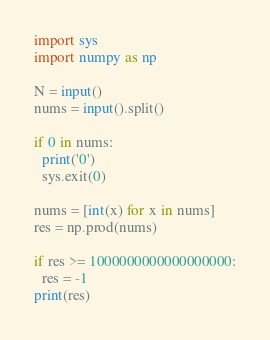Convert code to text. <code><loc_0><loc_0><loc_500><loc_500><_Python_>import sys
import numpy as np

N = input()
nums = input().split()
 
if 0 in nums:
  print('0')
  sys.exit(0)

nums = [int(x) for x in nums]
res = np.prod(nums)

if res >= 1000000000000000000:
  res = -1
print(res)</code> 